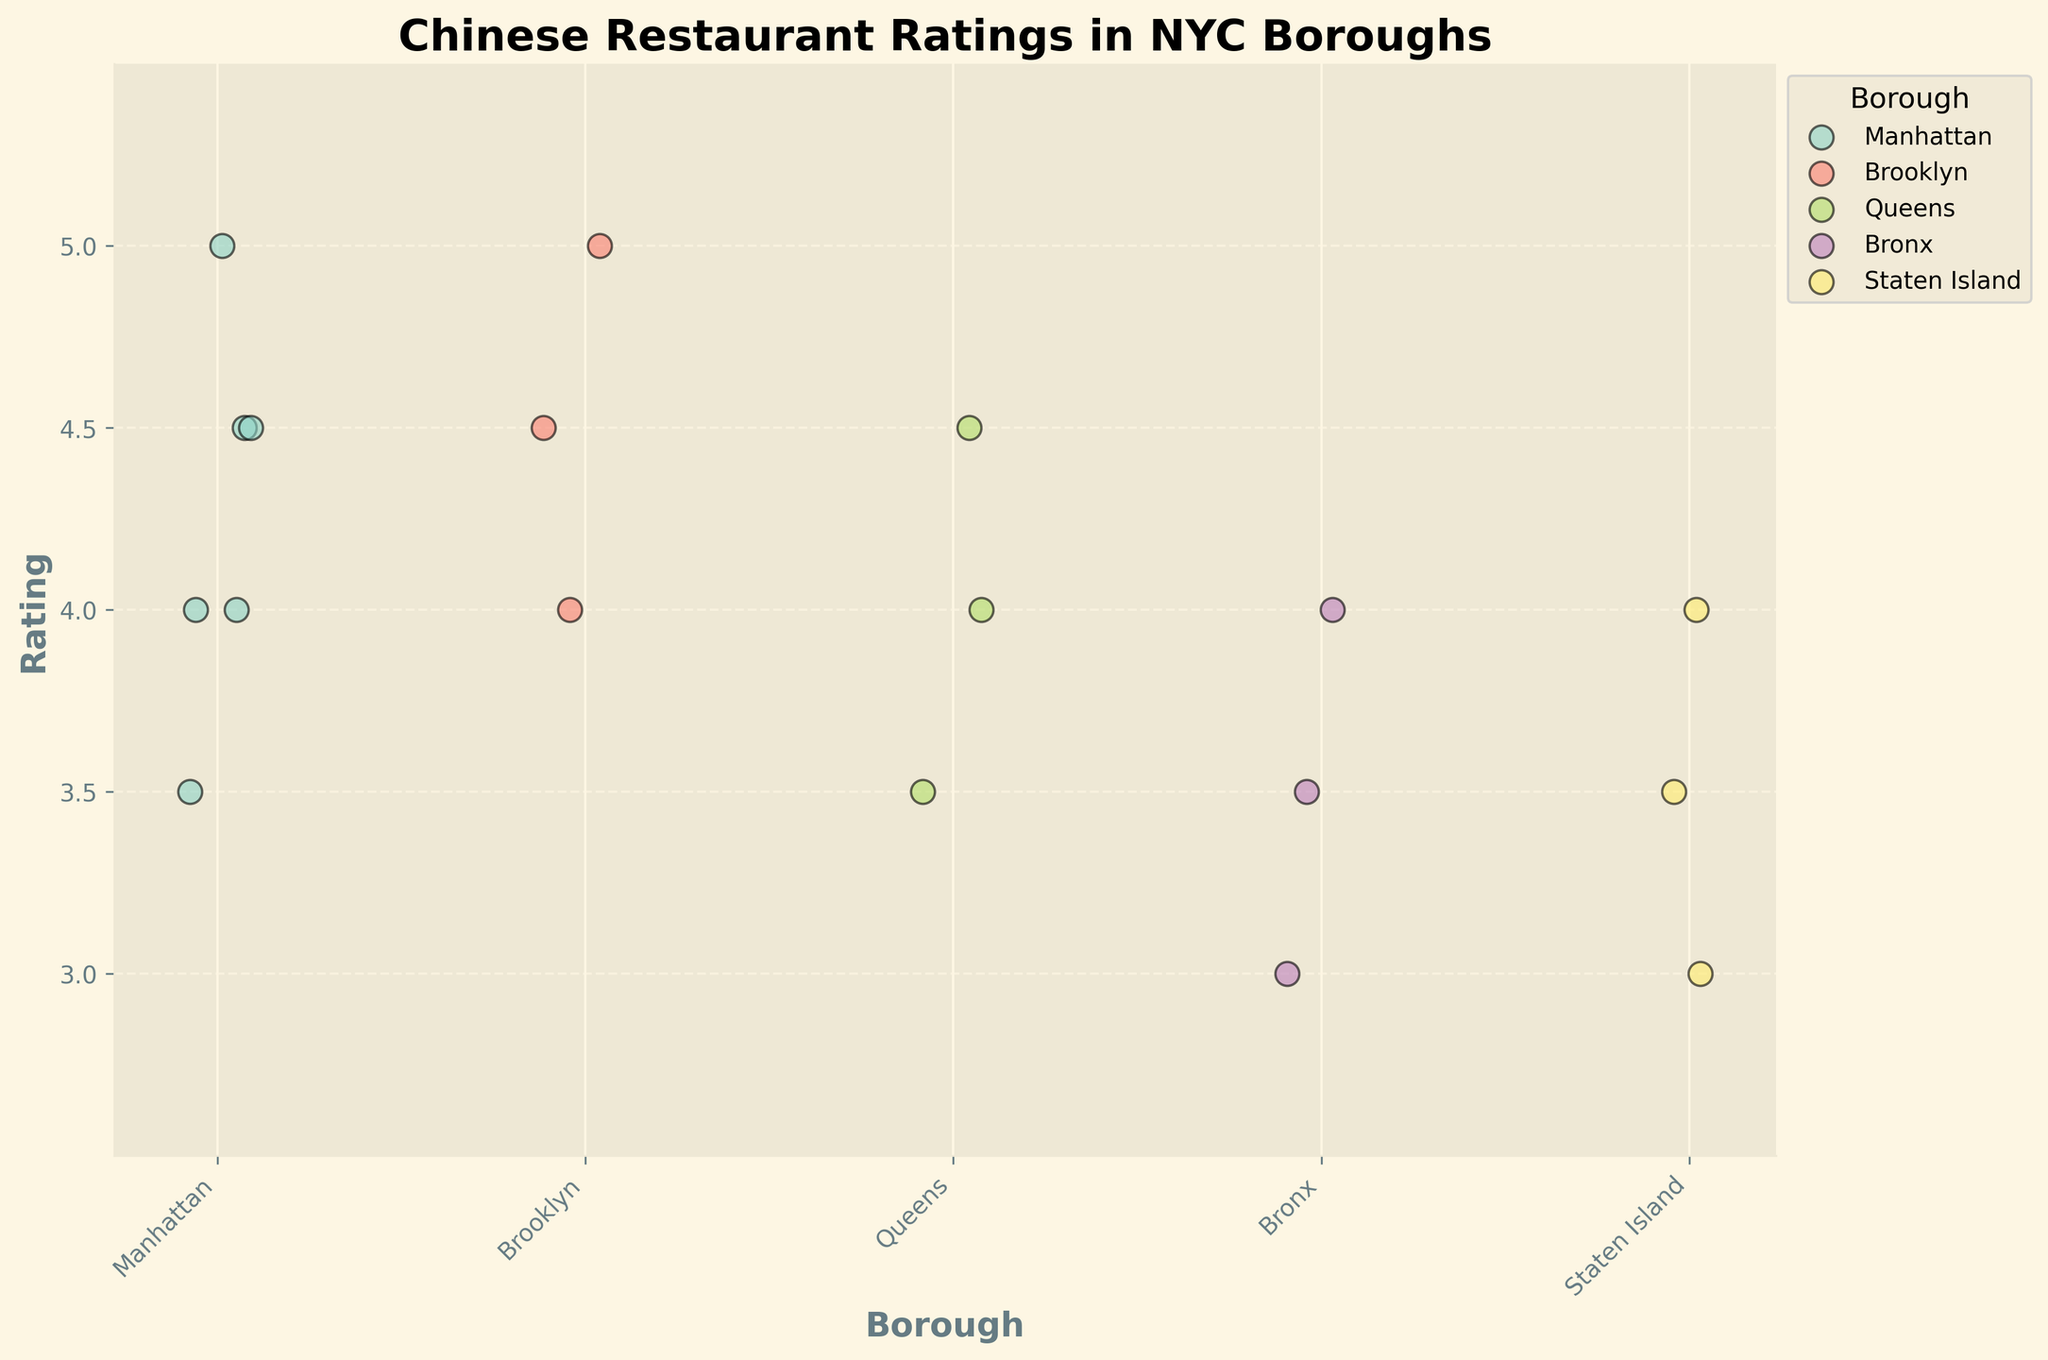What is the title of the plot? The title of the plot is written at the top of the figure.
Answer: Chinese Restaurant Ratings in NYC Boroughs Which borough has the highest individual restaurant rating? The scatter plot for each borough is color-coded and labeled. By looking at the highest points, Kings Co Imperial in Brooklyn has a rating of 5.0.
Answer: Brooklyn How many ratings are there for restaurants in Staten Island? Count the number of data points (dots) within the group labeled Staten Island on the x-axis.
Answer: 3 Which borough has the lowest individual restaurant rating? Look for the dot that is at the lowest position vertically. Staten Island has a rating of 3.0 for Jade Island.
Answer: Staten Island What is the range of the ratings for the restaurants in Manhattan? Identify the highest and lowest points for the Manhattan group: Joe's Shanghai ranges from 4.0 to 5.0, and Nom Wah Tea Parlor from 3.5 to 4.5, covering 3.5 to 5.0 overall.
Answer: 3.5 to 5.0 What is the average rating for Hunan House in Queens? Sum all the ratings for Hunan House (4.0 + 3.5 + 4.5) and divide by the number of ratings (3).
Answer: 4.0 Which borough has the most consistent (least spread) ratings? Observe the spread or range of the data points for each borough. Bronx has ratings close together between 3.0 and 4.0 (Sabrosura).
Answer: Bronx Are there any restaurants with identical ratings within the same borough? If yes, provide an example. Look for overlapping dots within each borough group. For Sabrosura in the Bronx, there are two ratings of 3.5.
Answer: Yes, Sabrosura in the Bronx has two ratings of 3.5 Which borough shows the greatest variety in restaurant ratings? Compare the spread (range) of ratings in each borough. Manhattan and Staten Island have more varied ratings from 3.0 to 5.0 and 3.0 to 4.0 respectively but consider the broad distribution overall.
Answer: Manhattan 